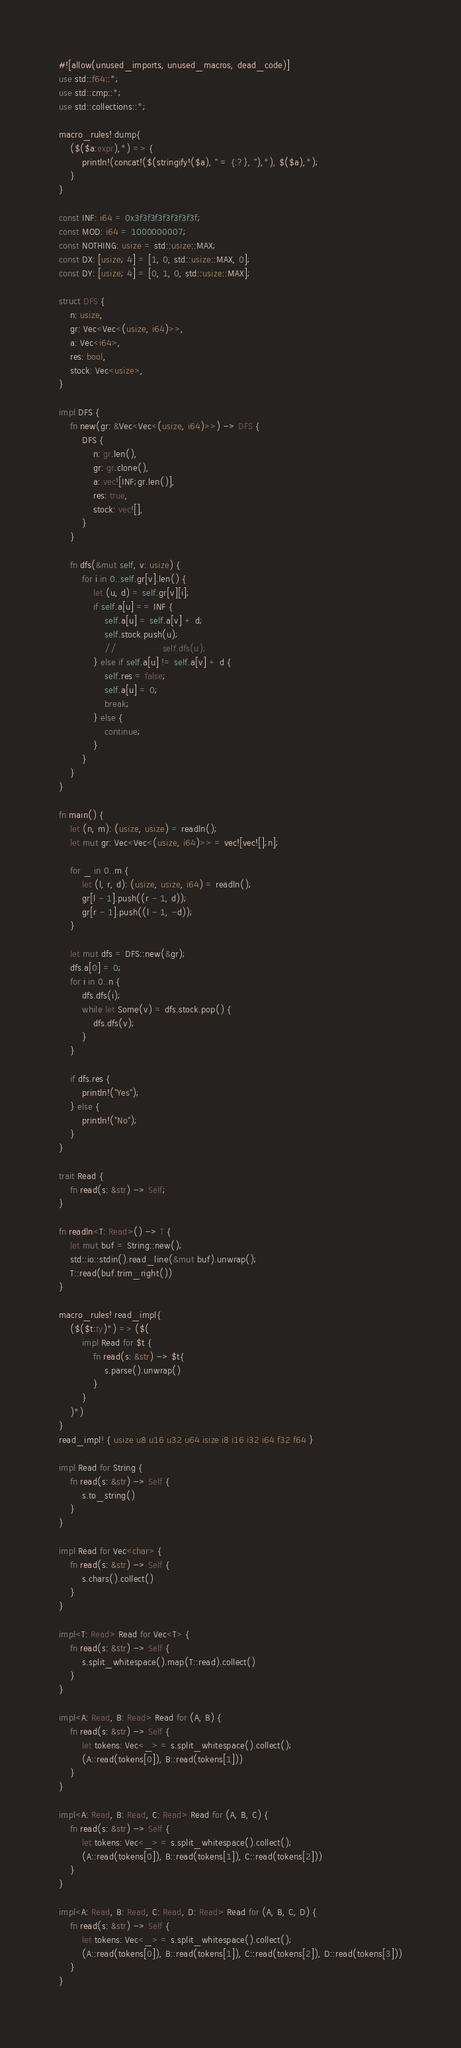Convert code to text. <code><loc_0><loc_0><loc_500><loc_500><_Rust_>#![allow(unused_imports, unused_macros, dead_code)]
use std::f64::*;
use std::cmp::*;
use std::collections::*;

macro_rules! dump{
    ($($a:expr),*) => {
        println!(concat!($(stringify!($a), " = {:?}, "),*), $($a),*);
    }
}

const INF: i64 = 0x3f3f3f3f3f3f3f3f;
const MOD: i64 = 1000000007;
const NOTHING: usize = std::usize::MAX;
const DX: [usize; 4] = [1, 0, std::usize::MAX, 0];
const DY: [usize; 4] = [0, 1, 0, std::usize::MAX];

struct DFS {
    n: usize,
    gr: Vec<Vec<(usize, i64)>>,
    a: Vec<i64>,
    res: bool,
    stock: Vec<usize>,
}

impl DFS {
    fn new(gr: &Vec<Vec<(usize, i64)>>) -> DFS {
        DFS {
            n: gr.len(),
            gr: gr.clone(),
            a: vec![INF;gr.len()],
            res: true,
            stock: vec![],
        }
    }

    fn dfs(&mut self, v: usize) {
        for i in 0..self.gr[v].len() {
            let (u, d) = self.gr[v][i];
            if self.a[u] == INF {
                self.a[u] = self.a[v] + d;
                self.stock.push(u);
                //                self.dfs(u);
            } else if self.a[u] != self.a[v] + d {
                self.res = false;
                self.a[u] = 0;
                break;
            } else {
                continue;
            }
        }
    }
}

fn main() {
    let (n, m): (usize, usize) = readln();
    let mut gr: Vec<Vec<(usize, i64)>> = vec![vec![];n];

    for _ in 0..m {
        let (l, r, d): (usize, usize, i64) = readln();
        gr[l - 1].push((r - 1, d));
        gr[r - 1].push((l - 1, -d));
    }

    let mut dfs = DFS::new(&gr);
    dfs.a[0] = 0;
    for i in 0..n {
        dfs.dfs(i);
        while let Some(v) = dfs.stock.pop() {
            dfs.dfs(v);
        }
    }

    if dfs.res {
        println!("Yes");
    } else {
        println!("No");
    }
}

trait Read {
    fn read(s: &str) -> Self;
}

fn readln<T: Read>() -> T {
    let mut buf = String::new();
    std::io::stdin().read_line(&mut buf).unwrap();
    T::read(buf.trim_right())
}

macro_rules! read_impl{
    ($($t:ty)*) => ($(
        impl Read for $t {
            fn read(s: &str) -> $t{
                s.parse().unwrap()
            }
        }
    )*)
}
read_impl! { usize u8 u16 u32 u64 isize i8 i16 i32 i64 f32 f64 }

impl Read for String {
    fn read(s: &str) -> Self {
        s.to_string()
    }
}

impl Read for Vec<char> {
    fn read(s: &str) -> Self {
        s.chars().collect()
    }
}

impl<T: Read> Read for Vec<T> {
    fn read(s: &str) -> Self {
        s.split_whitespace().map(T::read).collect()
    }
}

impl<A: Read, B: Read> Read for (A, B) {
    fn read(s: &str) -> Self {
        let tokens: Vec<_> = s.split_whitespace().collect();
        (A::read(tokens[0]), B::read(tokens[1]))
    }
}

impl<A: Read, B: Read, C: Read> Read for (A, B, C) {
    fn read(s: &str) -> Self {
        let tokens: Vec<_> = s.split_whitespace().collect();
        (A::read(tokens[0]), B::read(tokens[1]), C::read(tokens[2]))
    }
}

impl<A: Read, B: Read, C: Read, D: Read> Read for (A, B, C, D) {
    fn read(s: &str) -> Self {
        let tokens: Vec<_> = s.split_whitespace().collect();
        (A::read(tokens[0]), B::read(tokens[1]), C::read(tokens[2]), D::read(tokens[3]))
    }
}
</code> 